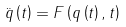<formula> <loc_0><loc_0><loc_500><loc_500>\ddot { q } \left ( t \right ) = F \left ( q \left ( t \right ) , t \right )</formula> 